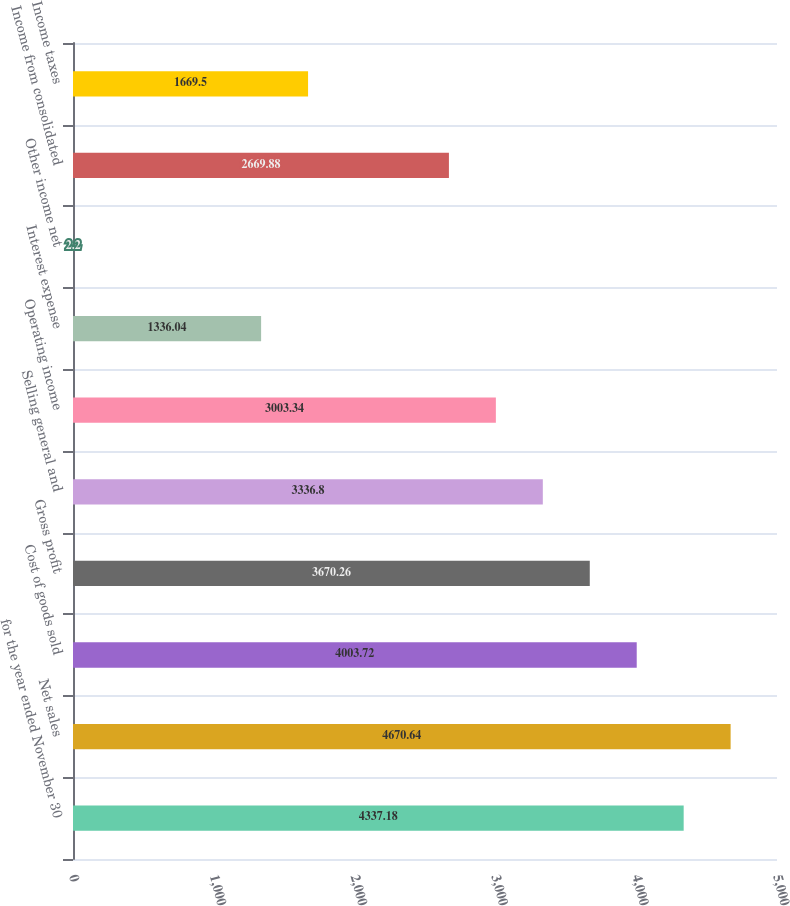<chart> <loc_0><loc_0><loc_500><loc_500><bar_chart><fcel>for the year ended November 30<fcel>Net sales<fcel>Cost of goods sold<fcel>Gross profit<fcel>Selling general and<fcel>Operating income<fcel>Interest expense<fcel>Other income net<fcel>Income from consolidated<fcel>Income taxes<nl><fcel>4337.18<fcel>4670.64<fcel>4003.72<fcel>3670.26<fcel>3336.8<fcel>3003.34<fcel>1336.04<fcel>2.2<fcel>2669.88<fcel>1669.5<nl></chart> 